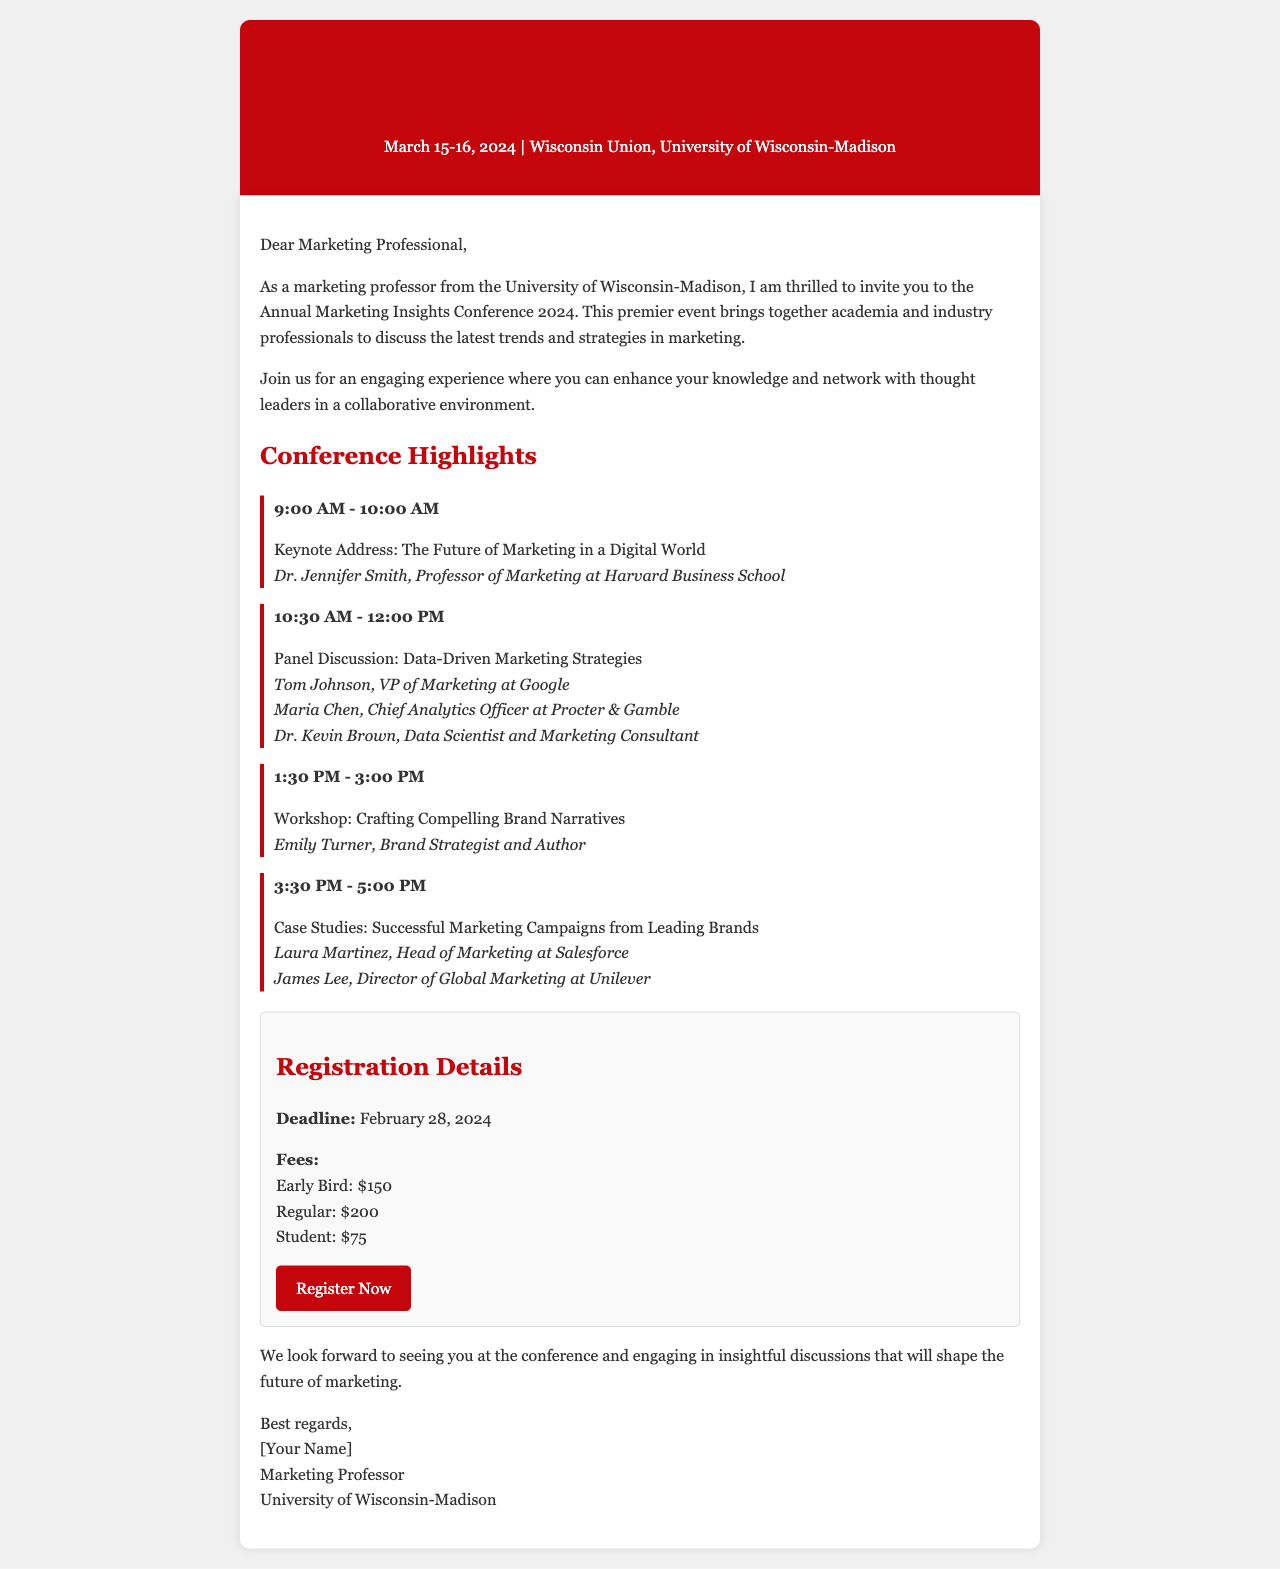What are the conference dates? The conference dates are mentioned at the beginning of the letter.
Answer: March 15-16, 2024 Who is the keynote speaker? The keynote speaker is listed in the conference highlights section.
Answer: Dr. Jennifer Smith What time does the keynote address start? The start time for the keynote address is specified in the agenda highlights.
Answer: 9:00 AM What is the registration deadline? The registration deadline is explicitly mentioned in the registration details section.
Answer: February 28, 2024 How much is the early bird registration fee? The early bird registration fee is outlined in the registration section of the document.
Answer: $150 What type of event is this conference? The nature of the event is described in the introduction of the letter.
Answer: Premiere event Who will participate in the panel discussion? The panel discussion participants are listed in the agenda section.
Answer: Tom Johnson, Maria Chen, Dr. Kevin Brown What workshop topic is scheduled after lunch? The workshop topic is specified in the agenda highlights section.
Answer: Crafting Compelling Brand Narratives Where is the conference held? The location of the conference is mentioned at the top of the letter.
Answer: Wisconsin Union, University of Wisconsin-Madison 